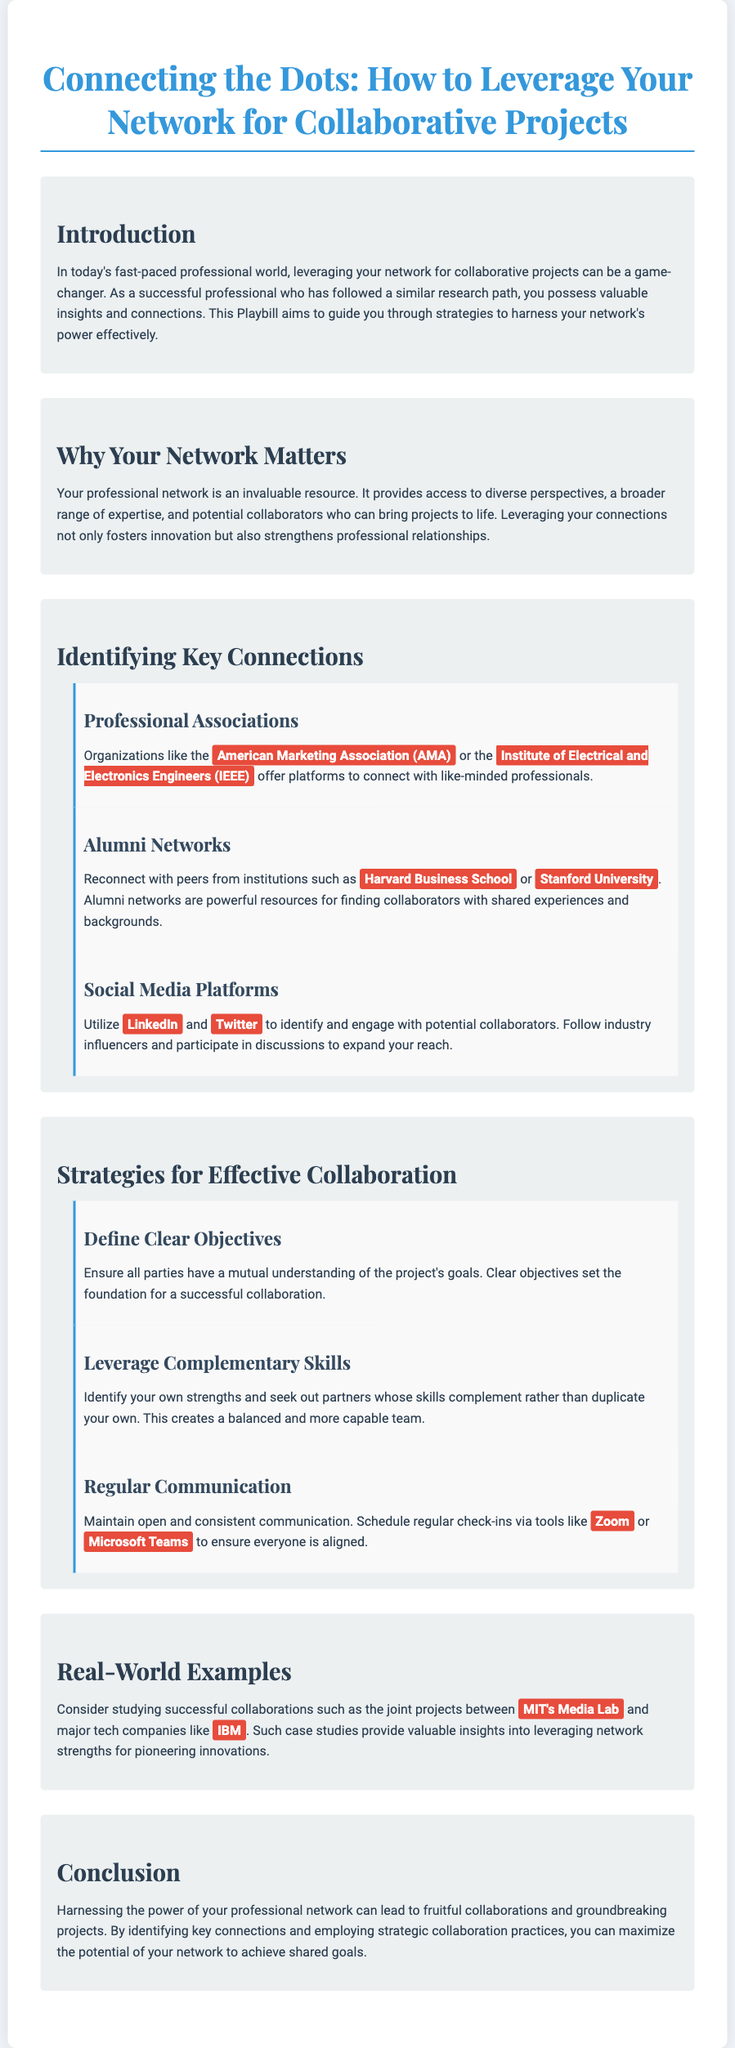What is the title of the document? The title of the document is presented at the top and serves as the main focus of the Playbill.
Answer: Connecting the Dots: How to Leverage Your Network for Collaborative Projects What organization is mentioned as a professional association? The document identifies organizations that facilitate networking, specifically named in the sub-section about professional associations.
Answer: American Marketing Association Which social media platform is suggested for engaging with potential collaborators? The document specifies social media platforms that can be leveraged for networking purposes, citing examples in the relevant section.
Answer: LinkedIn What is one of the strategies for effective collaboration? The document outlines specific strategies, listing clear objectives as one of the fundamental practices for collaboration in the corresponding section.
Answer: Define Clear Objectives What type of organizations can you reconnect with through alumni networks? The document discusses the benefits of alumni networks and mentions specific institutions as examples, highlighting where connections can be made.
Answer: Harvard Business School What two tools are suggested for regular communication? The document lists tools that can facilitate consistent communication during collaborations, mentioned in the section about strategies for effective collaboration.
Answer: Zoom, Microsoft Teams Which case study is mentioned as a real-world example? The document provides an example of a successful collaboration, naming specific institutions that illustrate effective networking and collaboration.
Answer: MIT's Media Lab What enhances the potential of your professional network? The document concludes with reflections on the benefits of leveraging specific strategies and identifying connections that increase collaboration opportunities.
Answer: Strategic collaboration practices 